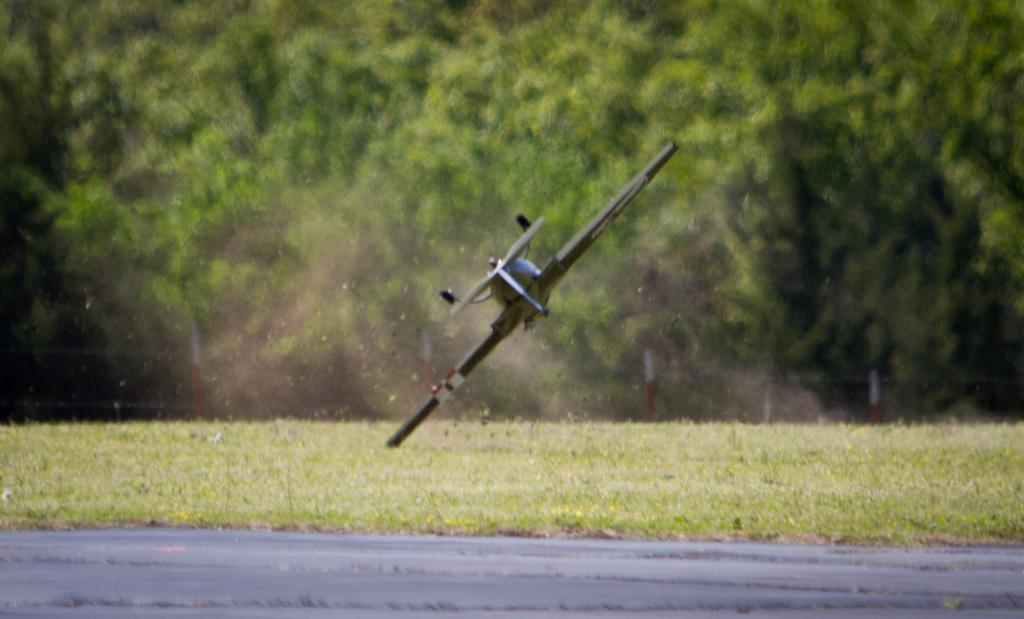What type of environment is shown in the image? The image is an outside view. What can be seen on the ground in the image? There is grass on the ground in the image. What is located at the bottom of the image? There is a road at the bottom of the image. What is the main subject in the middle of the image? There is an aircraft in the middle of the image. What is visible in the background of the image? There are many trees in the background of the image. How many plates are visible on the grass in the image? There are no plates visible in the image; it features an outside view with grass, a road, an aircraft, and trees. 